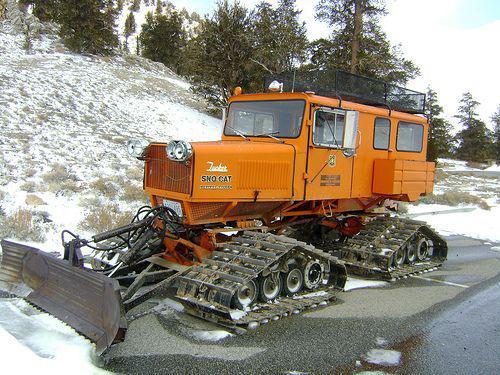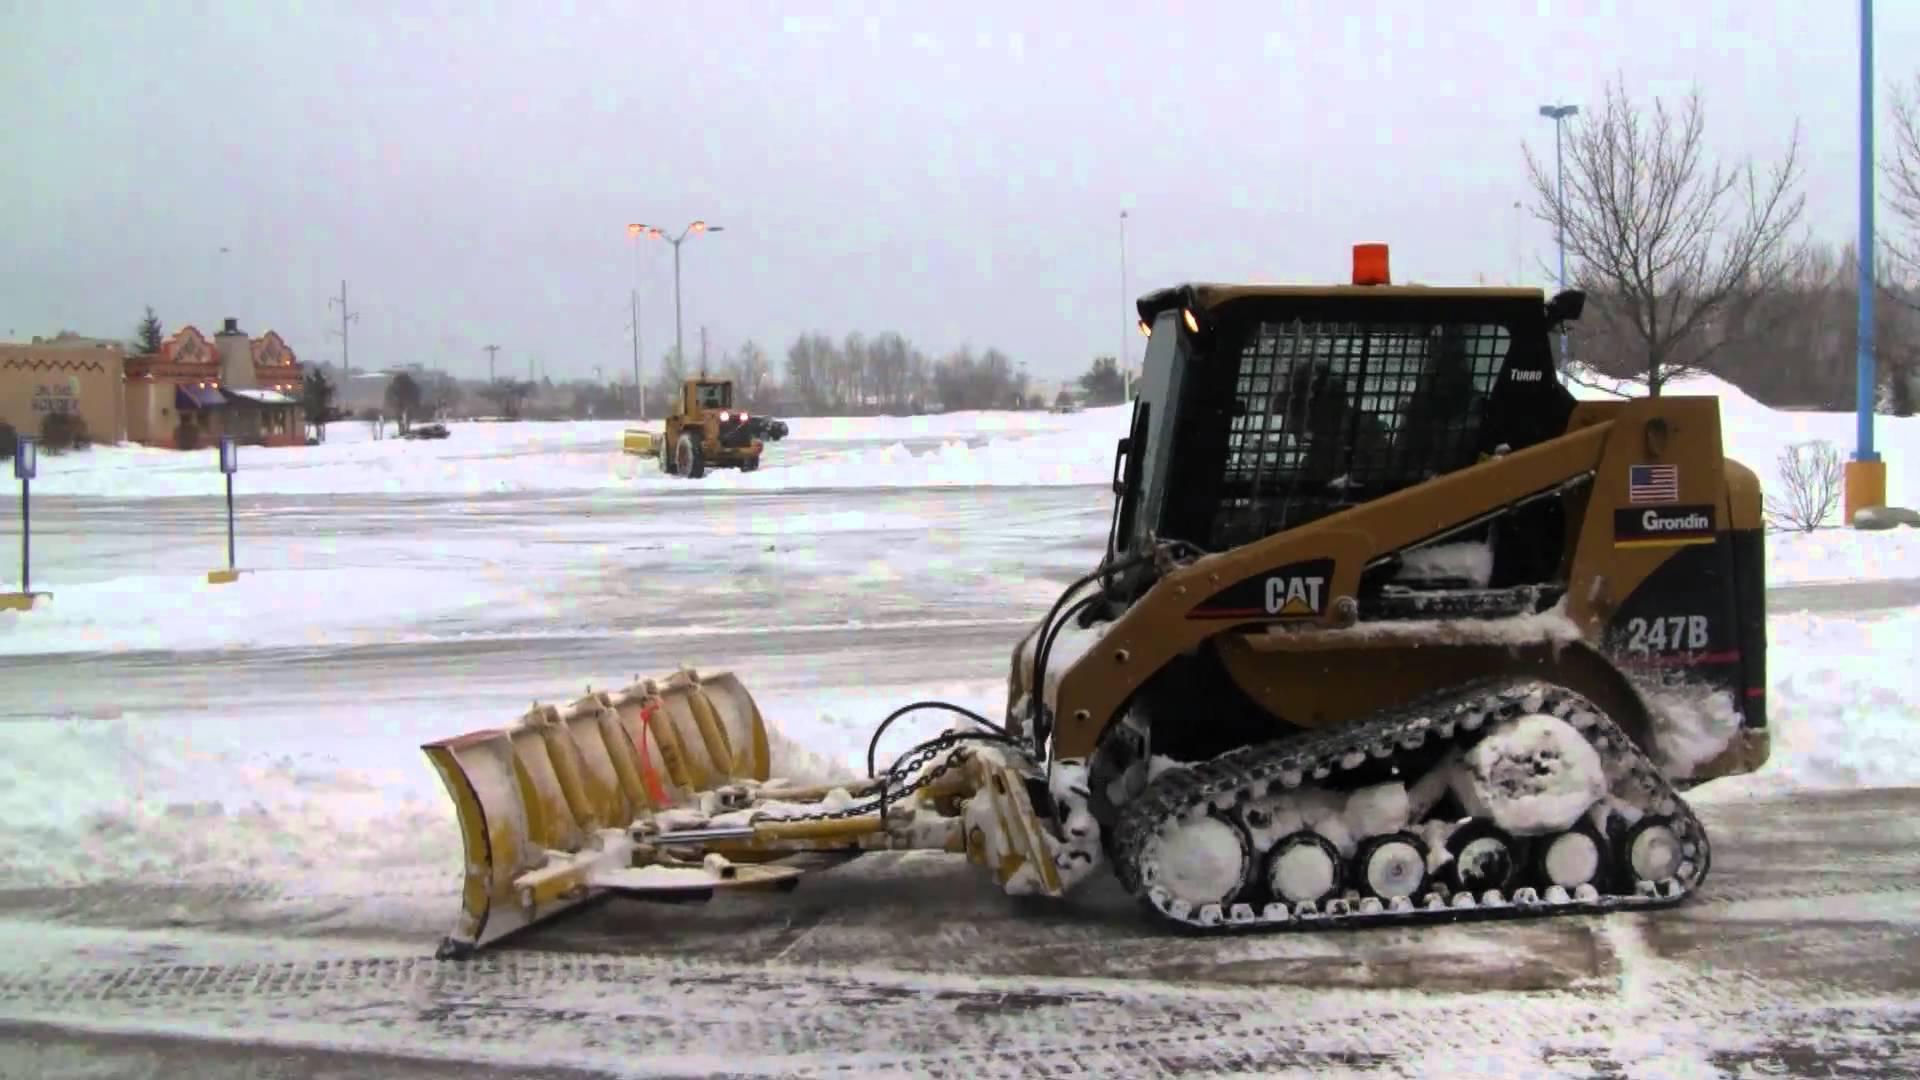The first image is the image on the left, the second image is the image on the right. Analyze the images presented: Is the assertion "one of the trucks is red" valid? Answer yes or no. No. 